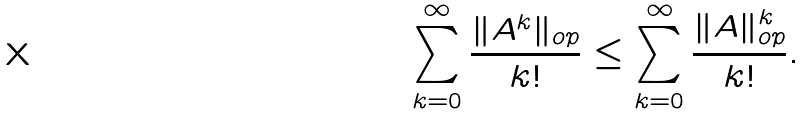Convert formula to latex. <formula><loc_0><loc_0><loc_500><loc_500>\sum _ { k = 0 } ^ { \infty } \frac { \| A ^ { k } \| _ { o p } } { k ! } \leq \sum _ { k = 0 } ^ { \infty } \frac { \| A \| _ { o p } ^ { k } } { k ! } .</formula> 